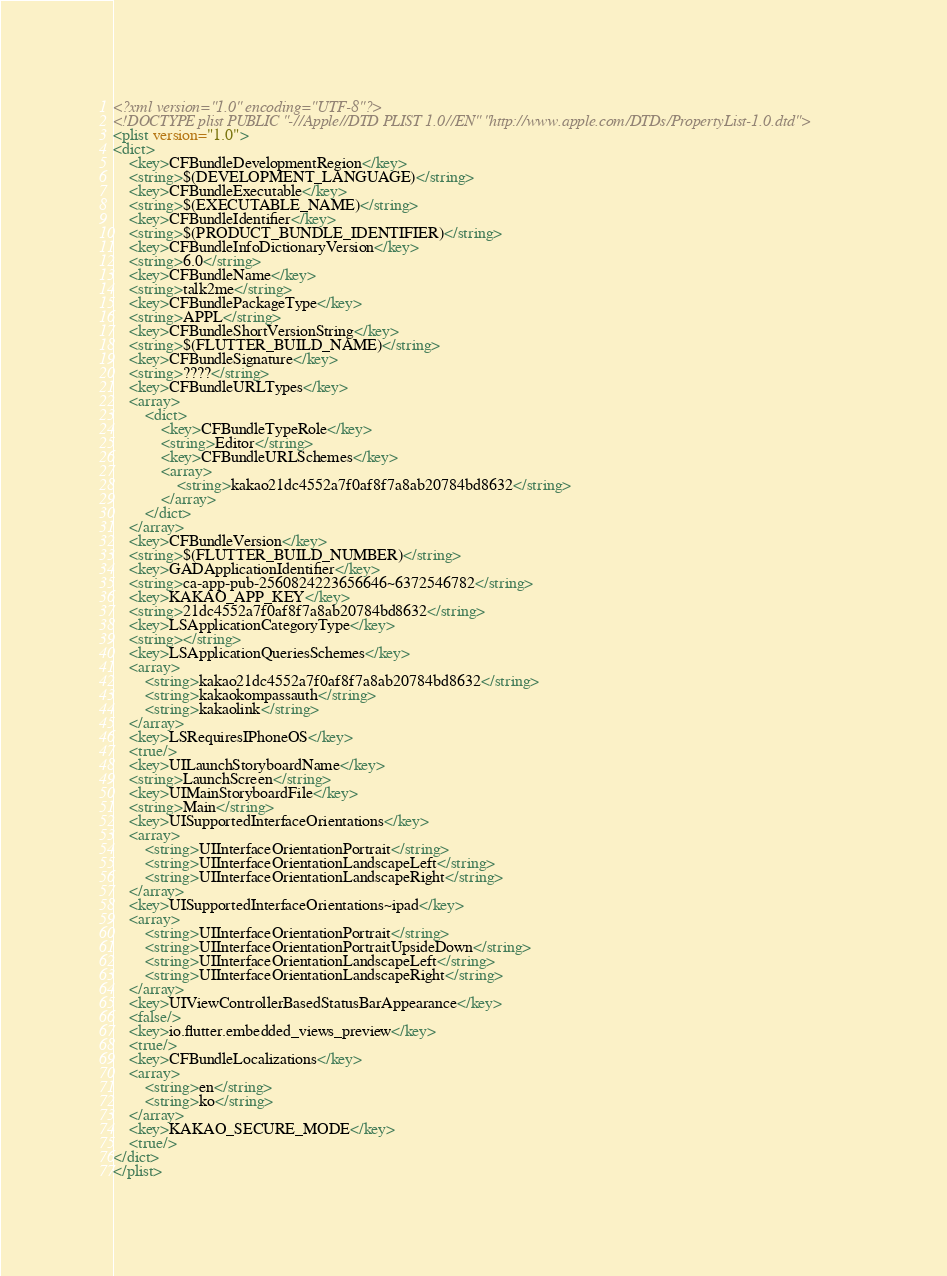<code> <loc_0><loc_0><loc_500><loc_500><_XML_><?xml version="1.0" encoding="UTF-8"?>
<!DOCTYPE plist PUBLIC "-//Apple//DTD PLIST 1.0//EN" "http://www.apple.com/DTDs/PropertyList-1.0.dtd">
<plist version="1.0">
<dict>
	<key>CFBundleDevelopmentRegion</key>
	<string>$(DEVELOPMENT_LANGUAGE)</string>
	<key>CFBundleExecutable</key>
	<string>$(EXECUTABLE_NAME)</string>
	<key>CFBundleIdentifier</key>
	<string>$(PRODUCT_BUNDLE_IDENTIFIER)</string>
	<key>CFBundleInfoDictionaryVersion</key>
	<string>6.0</string>
	<key>CFBundleName</key>
	<string>talk2me</string>
	<key>CFBundlePackageType</key>
	<string>APPL</string>
	<key>CFBundleShortVersionString</key>
	<string>$(FLUTTER_BUILD_NAME)</string>
	<key>CFBundleSignature</key>
	<string>????</string>
	<key>CFBundleURLTypes</key>
	<array>
		<dict>
			<key>CFBundleTypeRole</key>
			<string>Editor</string>
			<key>CFBundleURLSchemes</key>
			<array>
				<string>kakao21dc4552a7f0af8f7a8ab20784bd8632</string>
			</array>
		</dict>
	</array>
	<key>CFBundleVersion</key>
	<string>$(FLUTTER_BUILD_NUMBER)</string>
	<key>GADApplicationIdentifier</key>
	<string>ca-app-pub-2560824223656646~6372546782</string>
	<key>KAKAO_APP_KEY</key>
	<string>21dc4552a7f0af8f7a8ab20784bd8632</string>
	<key>LSApplicationCategoryType</key>
	<string></string>
	<key>LSApplicationQueriesSchemes</key>
	<array>
		<string>kakao21dc4552a7f0af8f7a8ab20784bd8632</string>
		<string>kakaokompassauth</string>
		<string>kakaolink</string>
	</array>
	<key>LSRequiresIPhoneOS</key>
	<true/>
	<key>UILaunchStoryboardName</key>
	<string>LaunchScreen</string>
	<key>UIMainStoryboardFile</key>
	<string>Main</string>
	<key>UISupportedInterfaceOrientations</key>
	<array>
		<string>UIInterfaceOrientationPortrait</string>
		<string>UIInterfaceOrientationLandscapeLeft</string>
		<string>UIInterfaceOrientationLandscapeRight</string>
	</array>
	<key>UISupportedInterfaceOrientations~ipad</key>
	<array>
		<string>UIInterfaceOrientationPortrait</string>
		<string>UIInterfaceOrientationPortraitUpsideDown</string>
		<string>UIInterfaceOrientationLandscapeLeft</string>
		<string>UIInterfaceOrientationLandscapeRight</string>
	</array>
	<key>UIViewControllerBasedStatusBarAppearance</key>
	<false/>
	<key>io.flutter.embedded_views_preview</key>
	<true/>
	<key>CFBundleLocalizations</key>
	<array>
		<string>en</string>
		<string>ko</string>
	</array>
    <key>KAKAO_SECURE_MODE</key>
    <true/>
</dict>
</plist>
</code> 